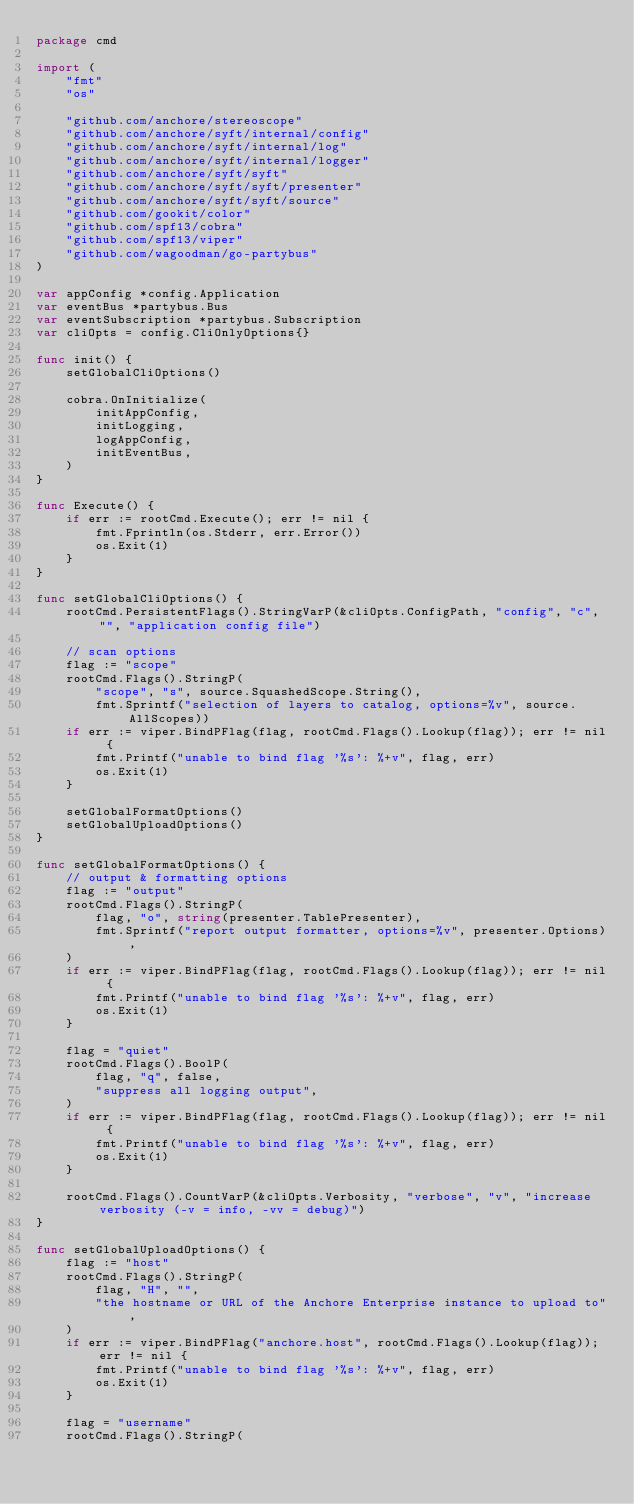<code> <loc_0><loc_0><loc_500><loc_500><_Go_>package cmd

import (
	"fmt"
	"os"

	"github.com/anchore/stereoscope"
	"github.com/anchore/syft/internal/config"
	"github.com/anchore/syft/internal/log"
	"github.com/anchore/syft/internal/logger"
	"github.com/anchore/syft/syft"
	"github.com/anchore/syft/syft/presenter"
	"github.com/anchore/syft/syft/source"
	"github.com/gookit/color"
	"github.com/spf13/cobra"
	"github.com/spf13/viper"
	"github.com/wagoodman/go-partybus"
)

var appConfig *config.Application
var eventBus *partybus.Bus
var eventSubscription *partybus.Subscription
var cliOpts = config.CliOnlyOptions{}

func init() {
	setGlobalCliOptions()

	cobra.OnInitialize(
		initAppConfig,
		initLogging,
		logAppConfig,
		initEventBus,
	)
}

func Execute() {
	if err := rootCmd.Execute(); err != nil {
		fmt.Fprintln(os.Stderr, err.Error())
		os.Exit(1)
	}
}

func setGlobalCliOptions() {
	rootCmd.PersistentFlags().StringVarP(&cliOpts.ConfigPath, "config", "c", "", "application config file")

	// scan options
	flag := "scope"
	rootCmd.Flags().StringP(
		"scope", "s", source.SquashedScope.String(),
		fmt.Sprintf("selection of layers to catalog, options=%v", source.AllScopes))
	if err := viper.BindPFlag(flag, rootCmd.Flags().Lookup(flag)); err != nil {
		fmt.Printf("unable to bind flag '%s': %+v", flag, err)
		os.Exit(1)
	}

	setGlobalFormatOptions()
	setGlobalUploadOptions()
}

func setGlobalFormatOptions() {
	// output & formatting options
	flag := "output"
	rootCmd.Flags().StringP(
		flag, "o", string(presenter.TablePresenter),
		fmt.Sprintf("report output formatter, options=%v", presenter.Options),
	)
	if err := viper.BindPFlag(flag, rootCmd.Flags().Lookup(flag)); err != nil {
		fmt.Printf("unable to bind flag '%s': %+v", flag, err)
		os.Exit(1)
	}

	flag = "quiet"
	rootCmd.Flags().BoolP(
		flag, "q", false,
		"suppress all logging output",
	)
	if err := viper.BindPFlag(flag, rootCmd.Flags().Lookup(flag)); err != nil {
		fmt.Printf("unable to bind flag '%s': %+v", flag, err)
		os.Exit(1)
	}

	rootCmd.Flags().CountVarP(&cliOpts.Verbosity, "verbose", "v", "increase verbosity (-v = info, -vv = debug)")
}

func setGlobalUploadOptions() {
	flag := "host"
	rootCmd.Flags().StringP(
		flag, "H", "",
		"the hostname or URL of the Anchore Enterprise instance to upload to",
	)
	if err := viper.BindPFlag("anchore.host", rootCmd.Flags().Lookup(flag)); err != nil {
		fmt.Printf("unable to bind flag '%s': %+v", flag, err)
		os.Exit(1)
	}

	flag = "username"
	rootCmd.Flags().StringP(</code> 